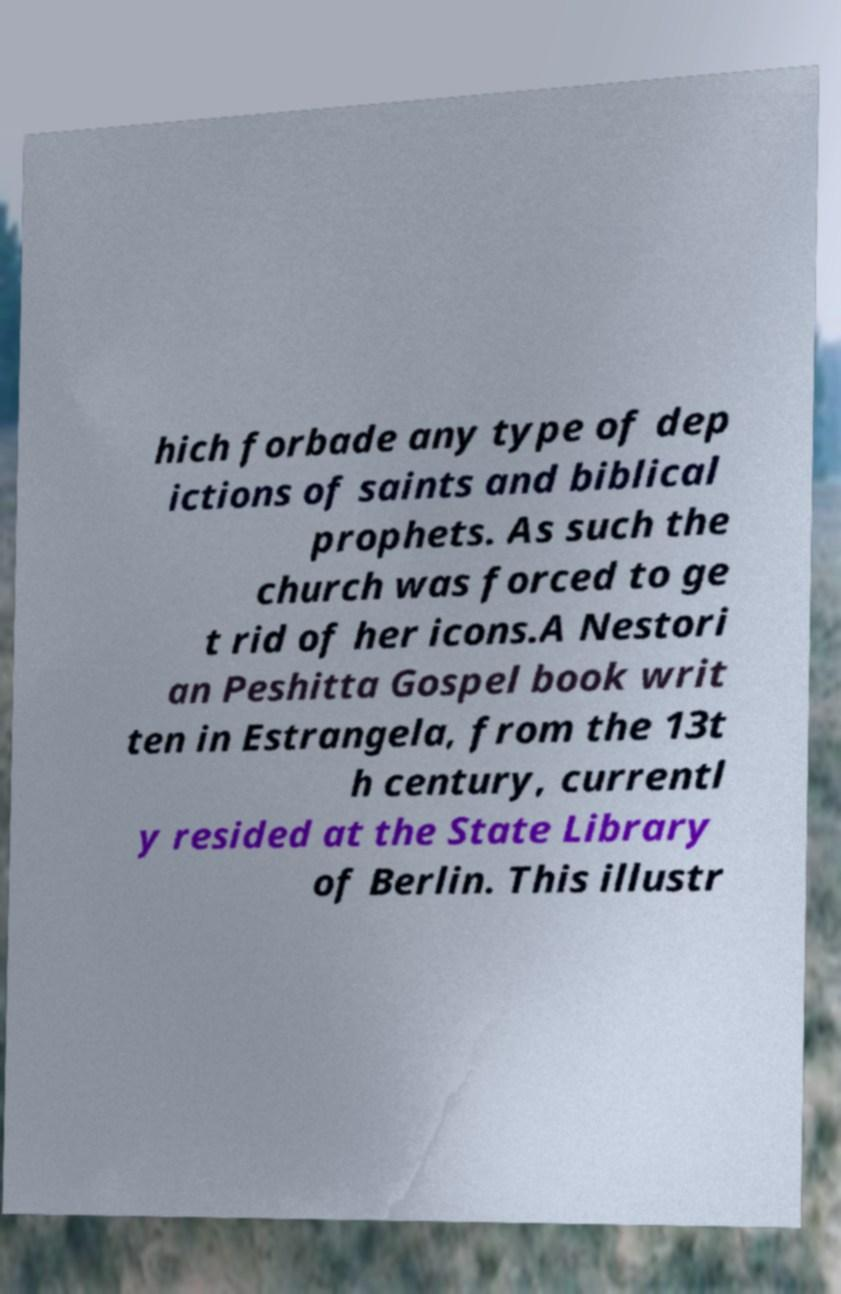Please read and relay the text visible in this image. What does it say? hich forbade any type of dep ictions of saints and biblical prophets. As such the church was forced to ge t rid of her icons.A Nestori an Peshitta Gospel book writ ten in Estrangela, from the 13t h century, currentl y resided at the State Library of Berlin. This illustr 